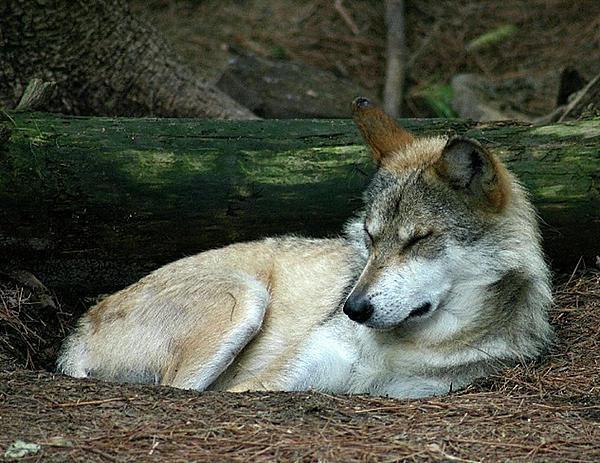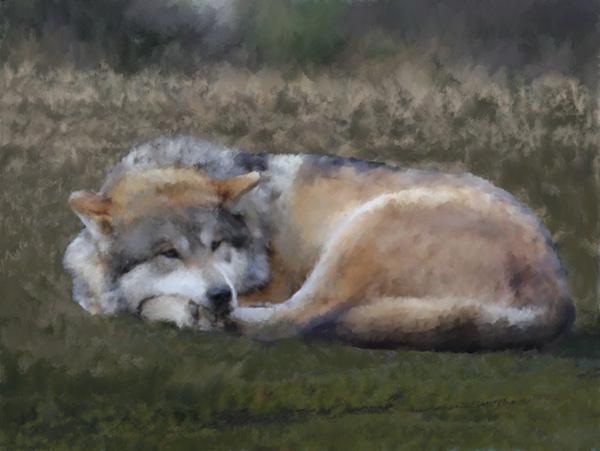The first image is the image on the left, the second image is the image on the right. Examine the images to the left and right. Is the description "One wolf's teeth are visible." accurate? Answer yes or no. No. The first image is the image on the left, the second image is the image on the right. For the images shown, is this caption "Both wolves are lying down and one is laying it's head on it's legs." true? Answer yes or no. Yes. 